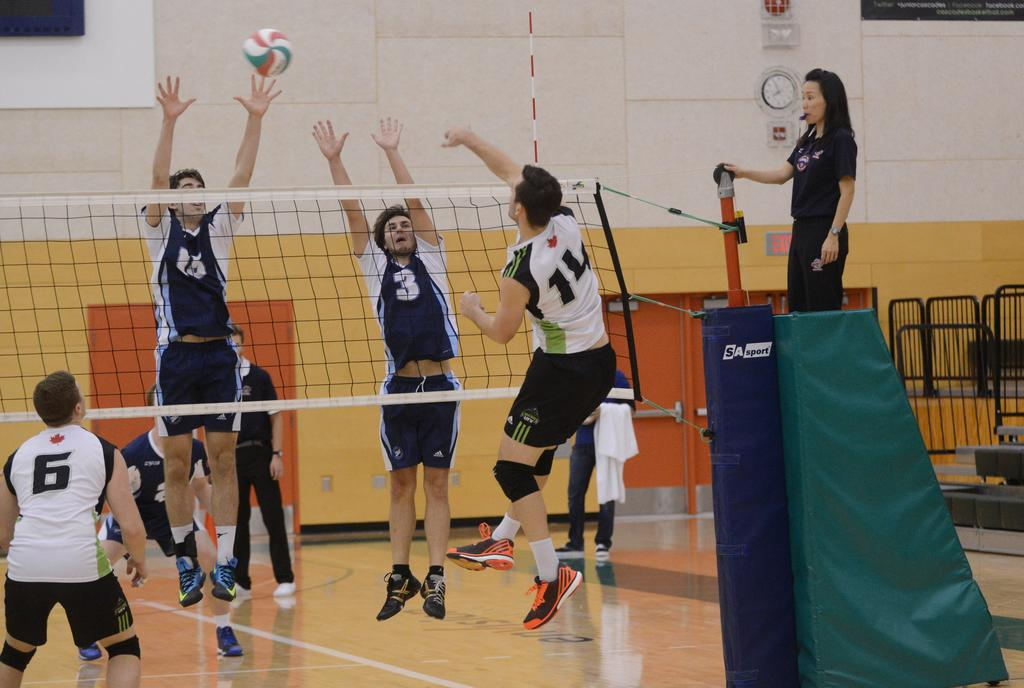<image>
Relay a brief, clear account of the picture shown. The clock in the upper right corner of the gym says it is 7:55. 